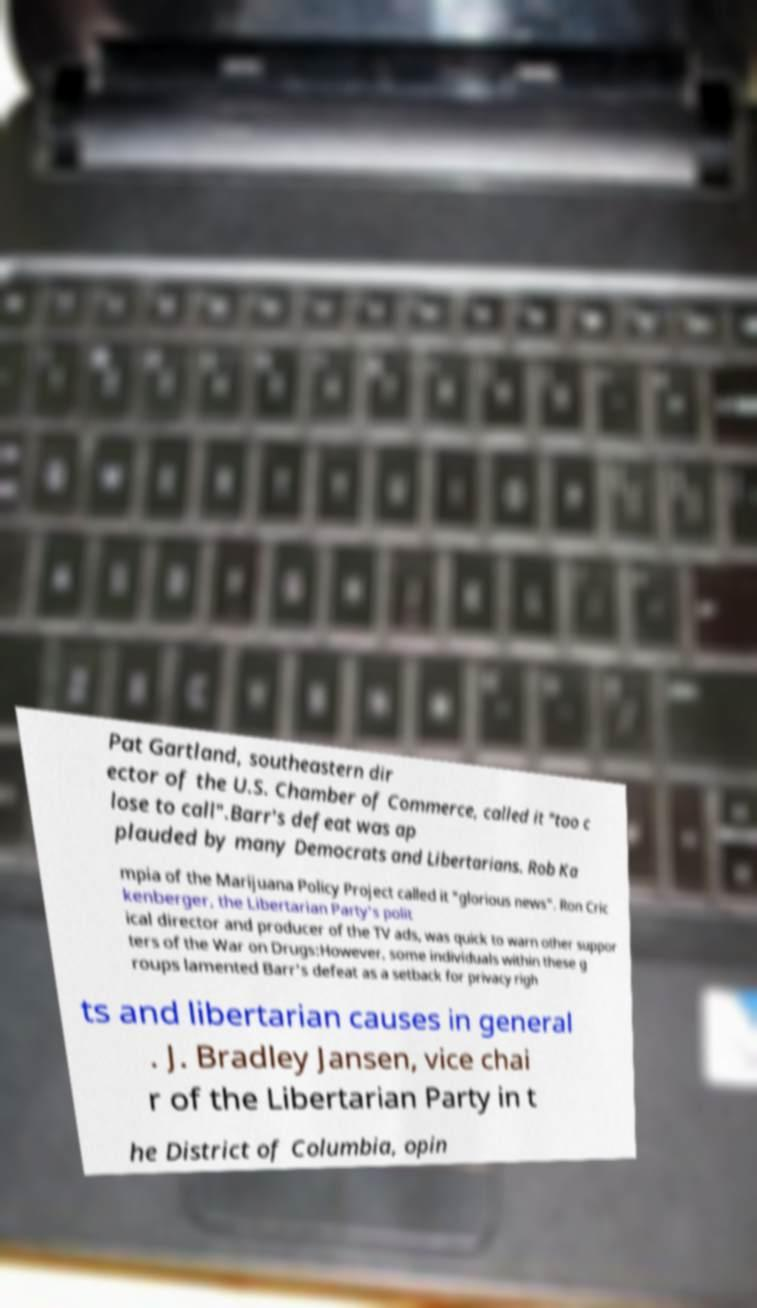Could you assist in decoding the text presented in this image and type it out clearly? Pat Gartland, southeastern dir ector of the U.S. Chamber of Commerce, called it "too c lose to call".Barr's defeat was ap plauded by many Democrats and Libertarians. Rob Ka mpia of the Marijuana Policy Project called it "glorious news". Ron Cric kenberger, the Libertarian Party's polit ical director and producer of the TV ads, was quick to warn other suppor ters of the War on Drugs:However, some individuals within these g roups lamented Barr's defeat as a setback for privacy righ ts and libertarian causes in general . J. Bradley Jansen, vice chai r of the Libertarian Party in t he District of Columbia, opin 